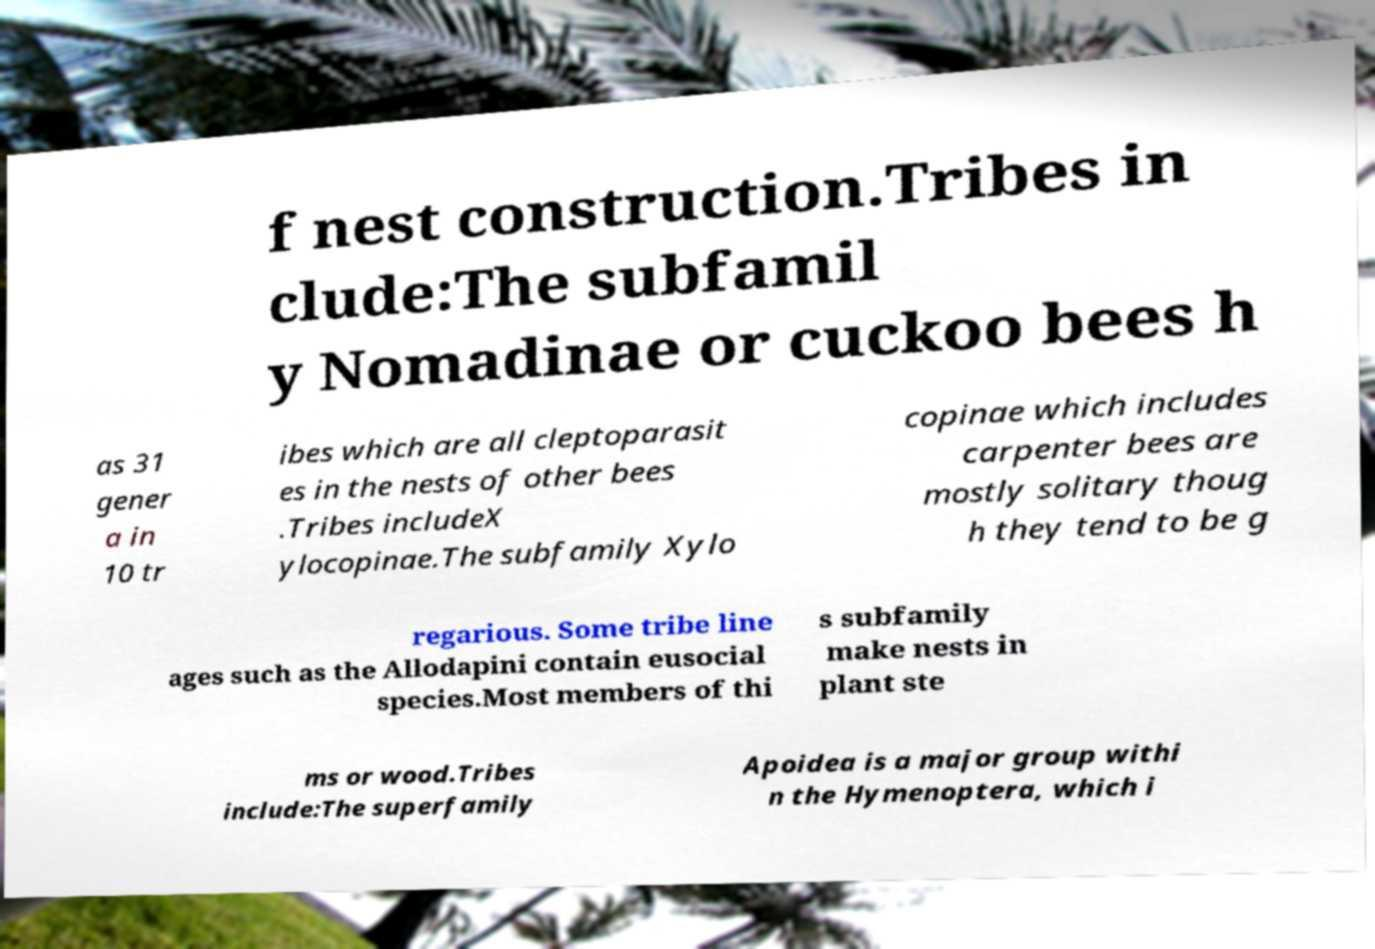Please read and relay the text visible in this image. What does it say? f nest construction.Tribes in clude:The subfamil y Nomadinae or cuckoo bees h as 31 gener a in 10 tr ibes which are all cleptoparasit es in the nests of other bees .Tribes includeX ylocopinae.The subfamily Xylo copinae which includes carpenter bees are mostly solitary thoug h they tend to be g regarious. Some tribe line ages such as the Allodapini contain eusocial species.Most members of thi s subfamily make nests in plant ste ms or wood.Tribes include:The superfamily Apoidea is a major group withi n the Hymenoptera, which i 